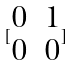<formula> <loc_0><loc_0><loc_500><loc_500>[ \begin{matrix} 0 & 1 \\ 0 & 0 \end{matrix} ]</formula> 